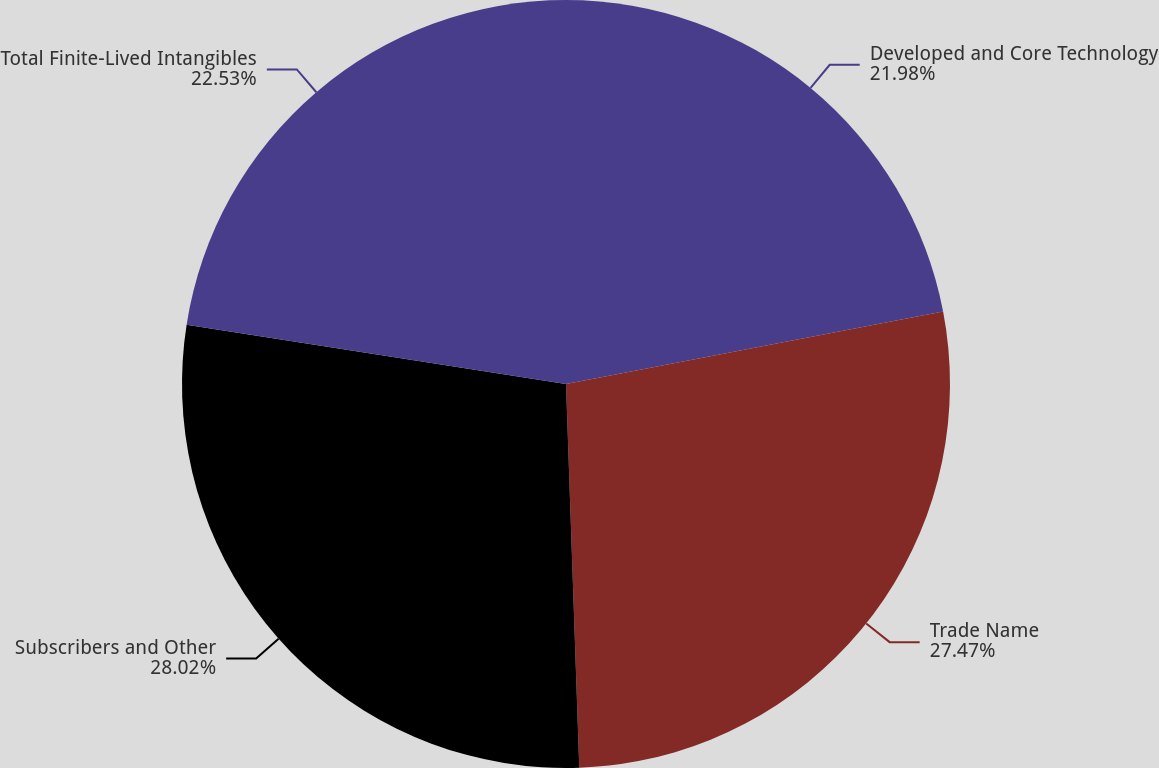<chart> <loc_0><loc_0><loc_500><loc_500><pie_chart><fcel>Developed and Core Technology<fcel>Trade Name<fcel>Subscribers and Other<fcel>Total Finite-Lived Intangibles<nl><fcel>21.98%<fcel>27.47%<fcel>28.02%<fcel>22.53%<nl></chart> 